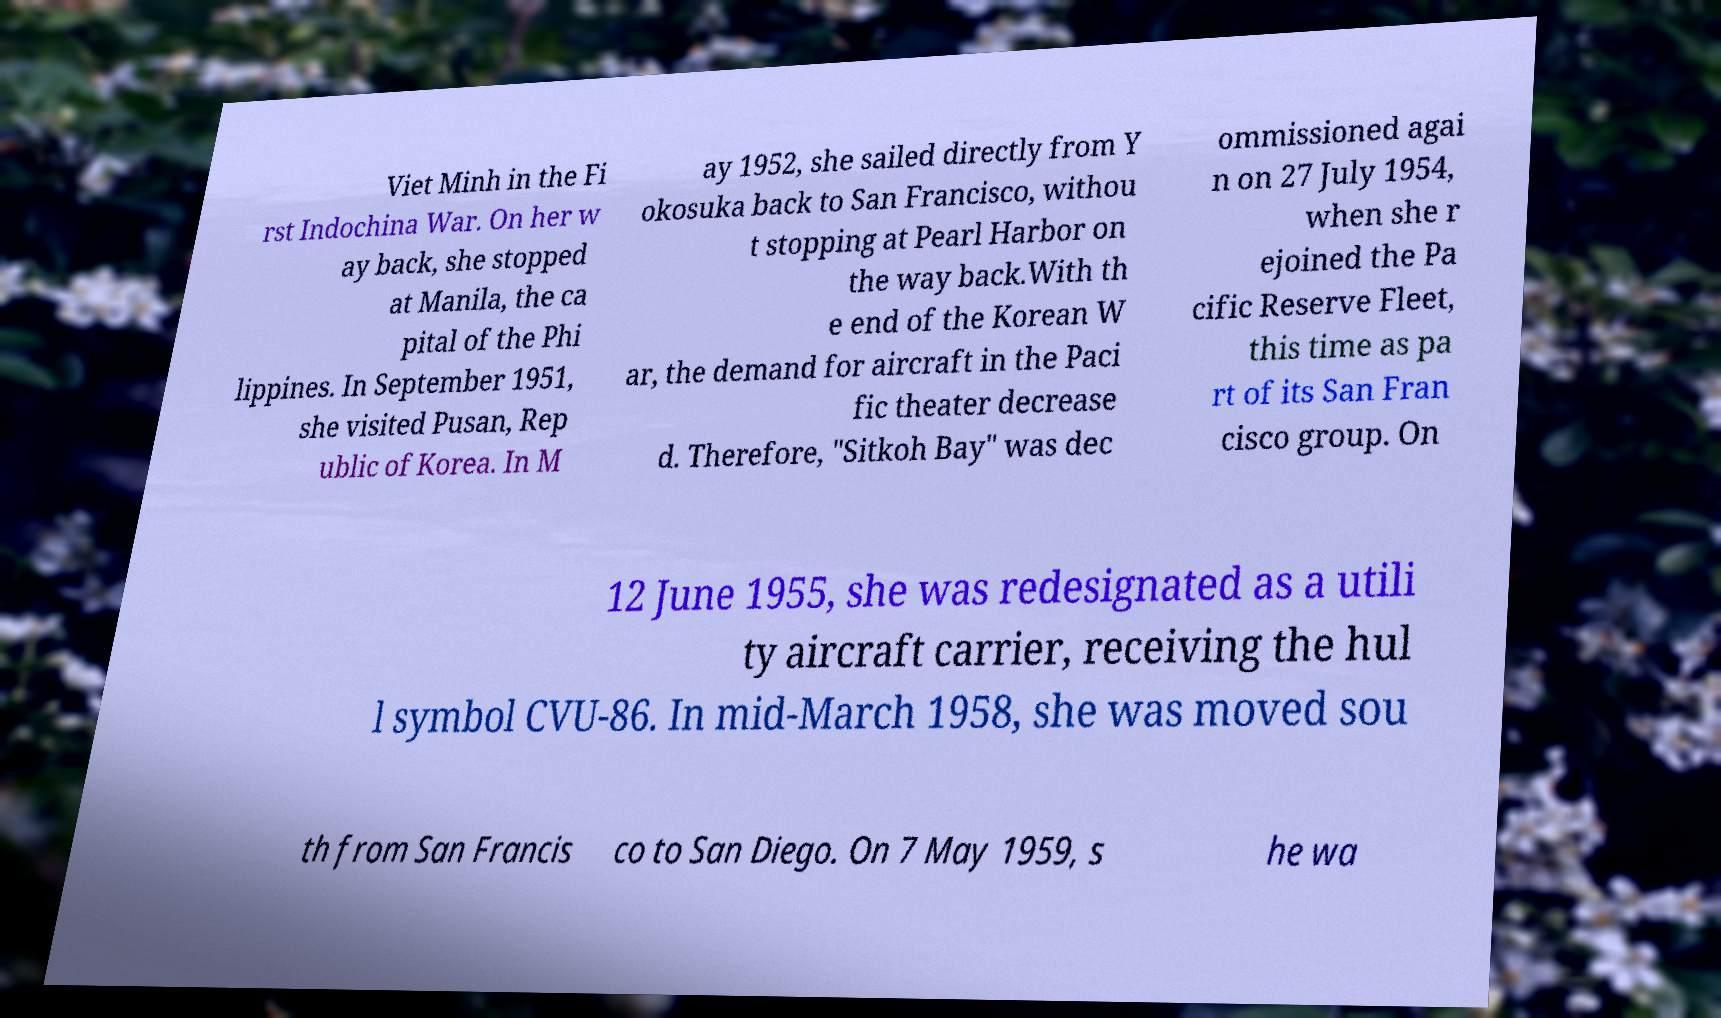I need the written content from this picture converted into text. Can you do that? Viet Minh in the Fi rst Indochina War. On her w ay back, she stopped at Manila, the ca pital of the Phi lippines. In September 1951, she visited Pusan, Rep ublic of Korea. In M ay 1952, she sailed directly from Y okosuka back to San Francisco, withou t stopping at Pearl Harbor on the way back.With th e end of the Korean W ar, the demand for aircraft in the Paci fic theater decrease d. Therefore, "Sitkoh Bay" was dec ommissioned agai n on 27 July 1954, when she r ejoined the Pa cific Reserve Fleet, this time as pa rt of its San Fran cisco group. On 12 June 1955, she was redesignated as a utili ty aircraft carrier, receiving the hul l symbol CVU-86. In mid-March 1958, she was moved sou th from San Francis co to San Diego. On 7 May 1959, s he wa 